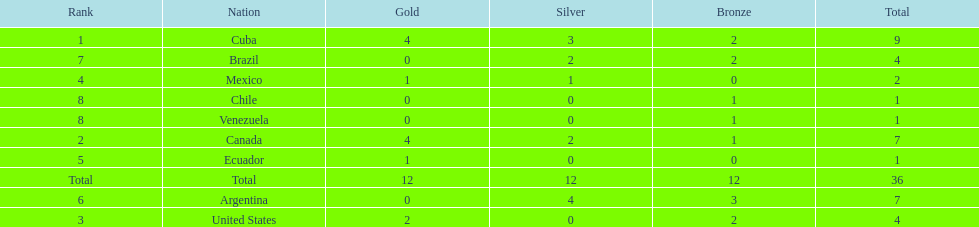How many total medals were there all together? 36. 